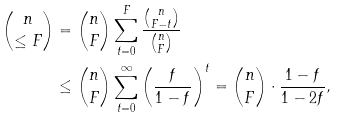<formula> <loc_0><loc_0><loc_500><loc_500>\binom { n } { \leq F } & = \binom { n } { F } \sum _ { t = 0 } ^ { F } \frac { \binom { n } { F - t } } { \binom { n } { F } } \\ & \leq \binom { n } { F } \sum _ { t = 0 } ^ { \infty } \left ( \frac { f } { 1 - f } \right ) ^ { t } = \binom { n } { F } \cdot \frac { 1 - f } { 1 - 2 f } ,</formula> 